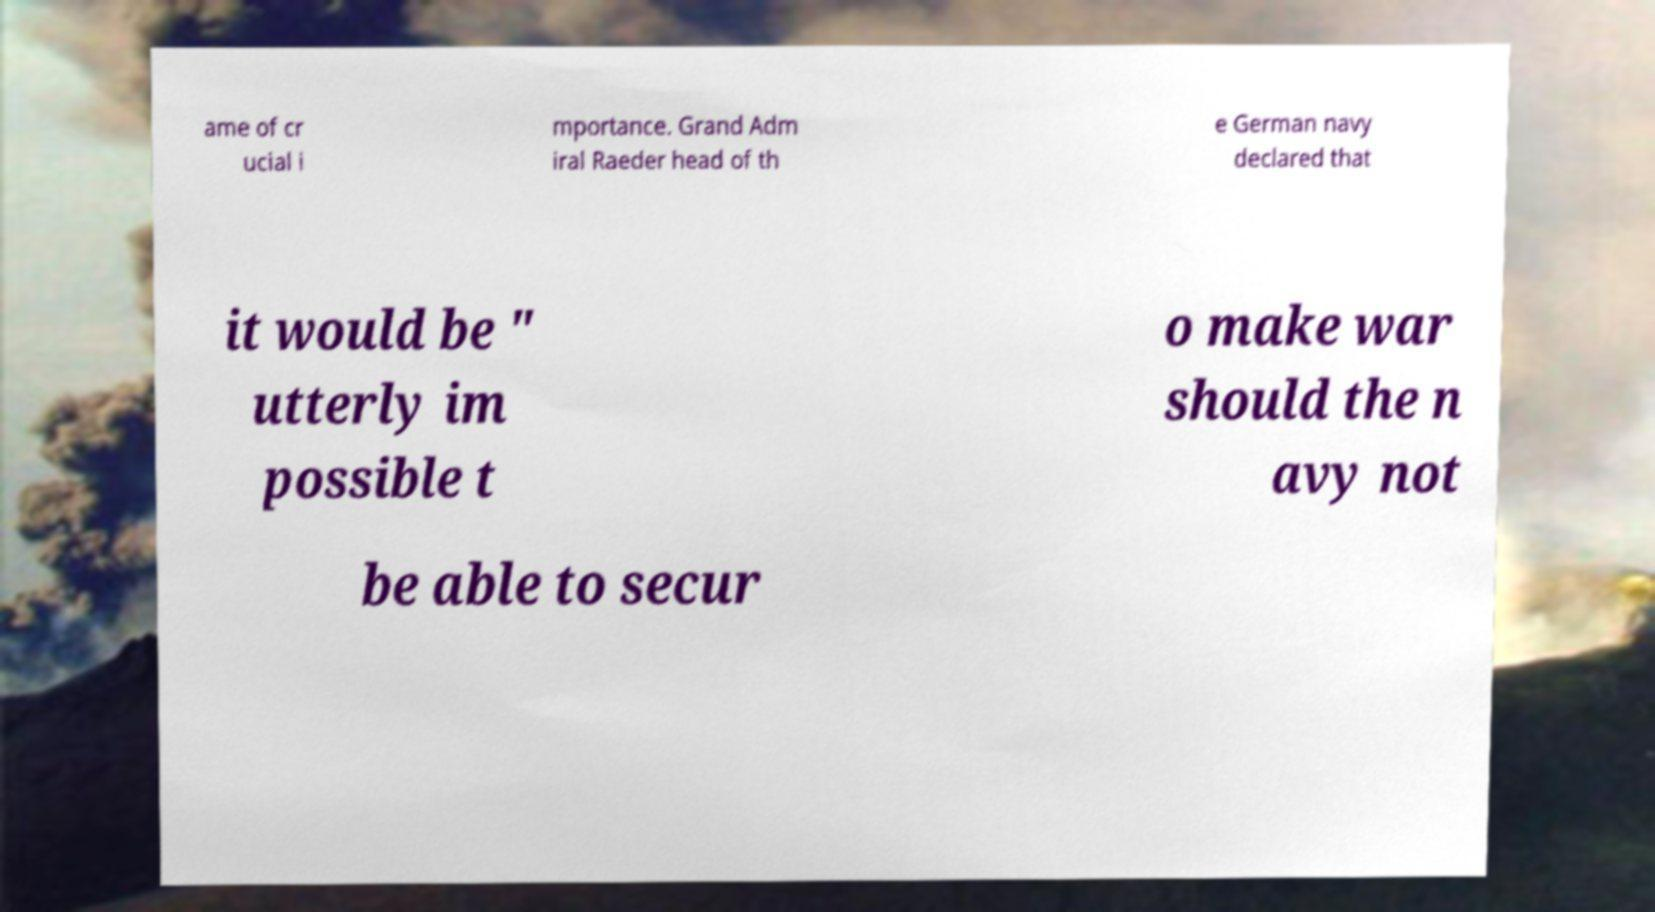What messages or text are displayed in this image? I need them in a readable, typed format. ame of cr ucial i mportance. Grand Adm iral Raeder head of th e German navy declared that it would be " utterly im possible t o make war should the n avy not be able to secur 